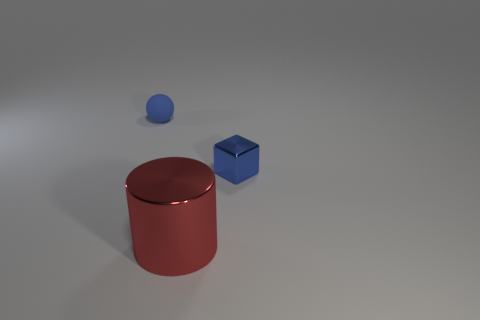Do the ball and the tiny cube have the same color?
Offer a terse response. Yes. Is there any other thing that has the same shape as the blue rubber object?
Your answer should be very brief. No. There is a ball that is the same color as the small cube; what is its material?
Make the answer very short. Rubber. What number of objects are both in front of the blue sphere and behind the big shiny object?
Your response must be concise. 1. What shape is the shiny thing that is the same size as the blue matte object?
Ensure brevity in your answer.  Cube. Are there any red metal things that are on the left side of the object that is behind the blue block to the right of the small ball?
Offer a very short reply. No. Is the color of the matte ball the same as the object that is on the right side of the large cylinder?
Keep it short and to the point. Yes. What number of other tiny balls are the same color as the small sphere?
Provide a succinct answer. 0. What is the size of the blue object that is in front of the blue object behind the small blue shiny cube?
Your answer should be very brief. Small. What number of objects are objects that are in front of the tiny blue rubber object or rubber cylinders?
Ensure brevity in your answer.  2. 